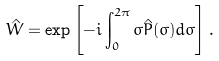Convert formula to latex. <formula><loc_0><loc_0><loc_500><loc_500>\hat { W } = \exp \left [ - i \int _ { 0 } ^ { 2 \pi } \sigma \hat { P } ( \sigma ) d \sigma \right ] .</formula> 